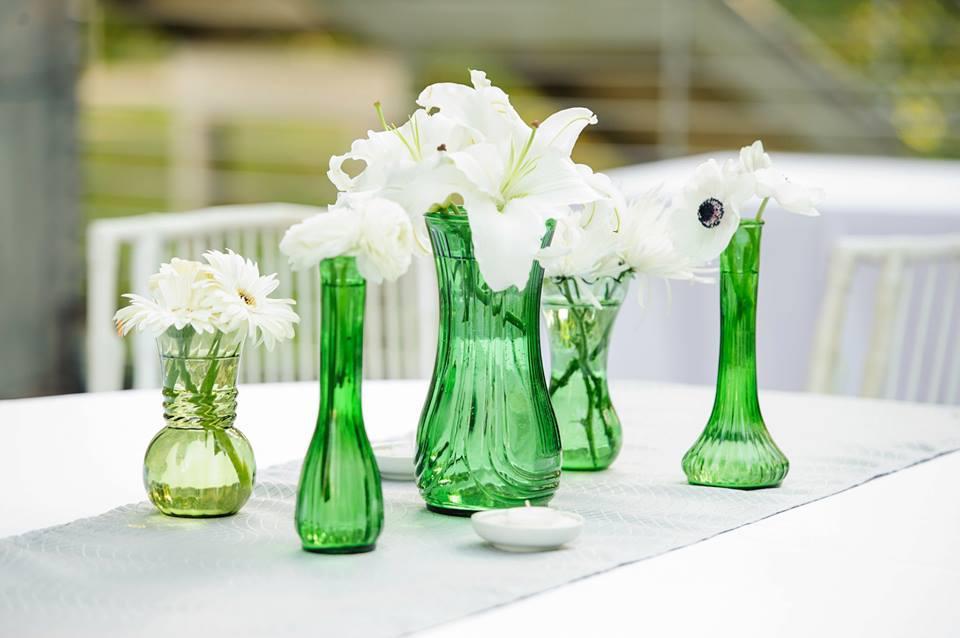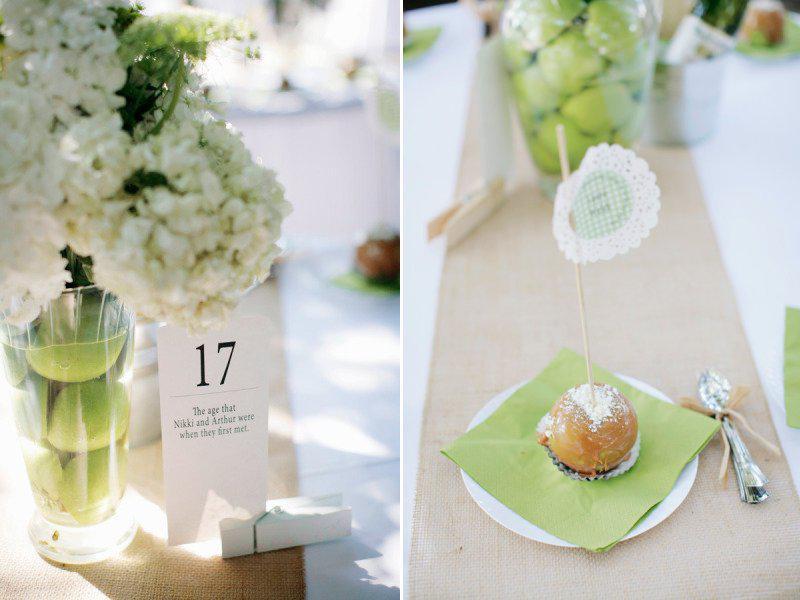The first image is the image on the left, the second image is the image on the right. Given the left and right images, does the statement "The vases in the left image are silver colored." hold true? Answer yes or no. No. The first image is the image on the left, the second image is the image on the right. Evaluate the accuracy of this statement regarding the images: "Two clear vases with green fruit in their water-filled bases are shown in the right image.". Is it true? Answer yes or no. Yes. 